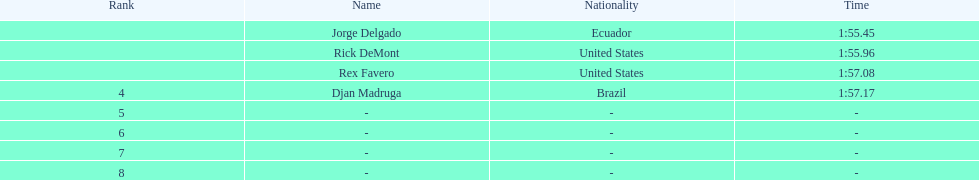What is the average time? 1:56.42. 